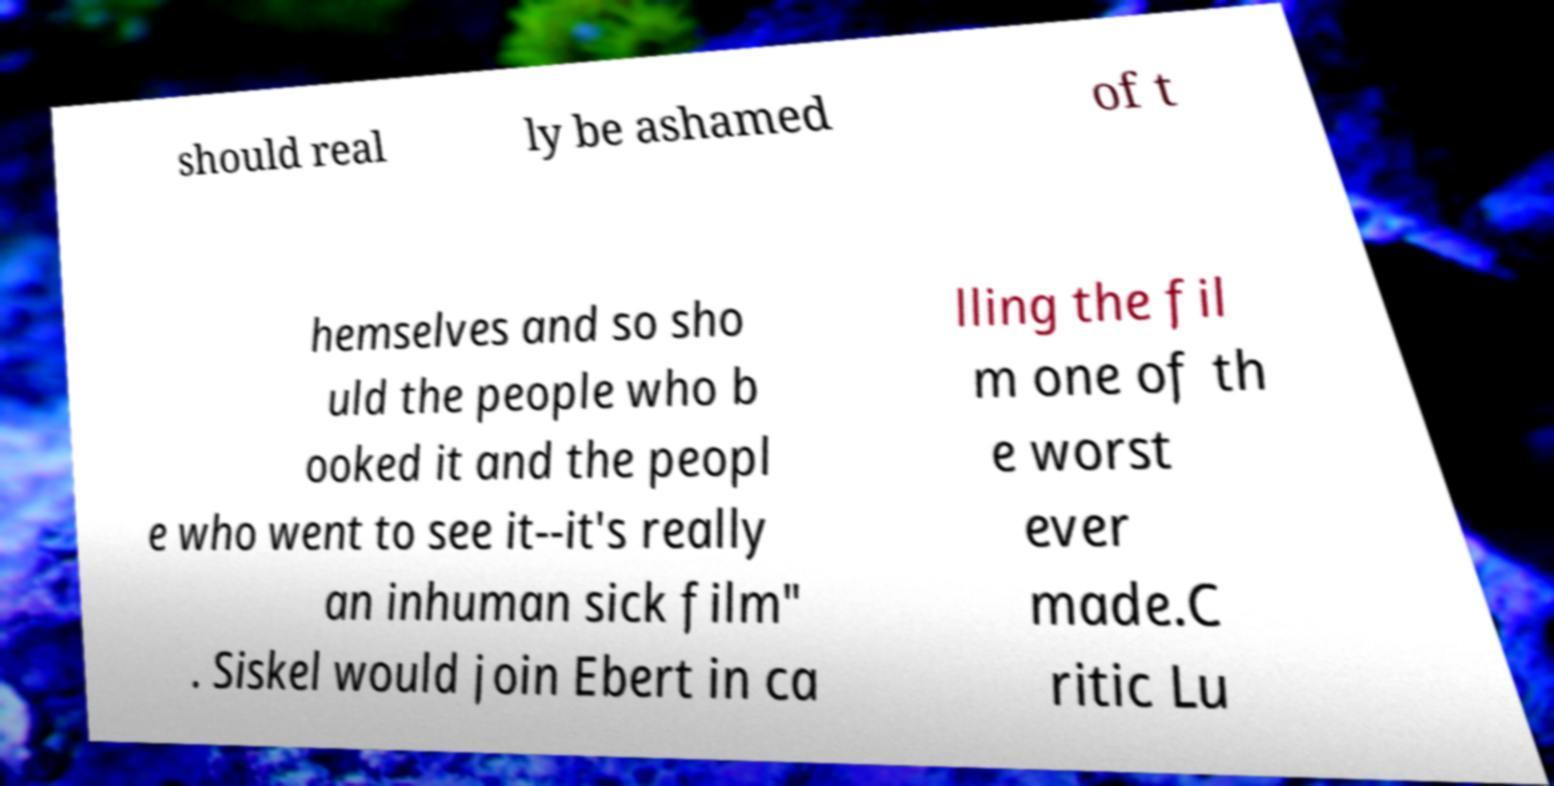Could you assist in decoding the text presented in this image and type it out clearly? should real ly be ashamed of t hemselves and so sho uld the people who b ooked it and the peopl e who went to see it--it's really an inhuman sick film" . Siskel would join Ebert in ca lling the fil m one of th e worst ever made.C ritic Lu 